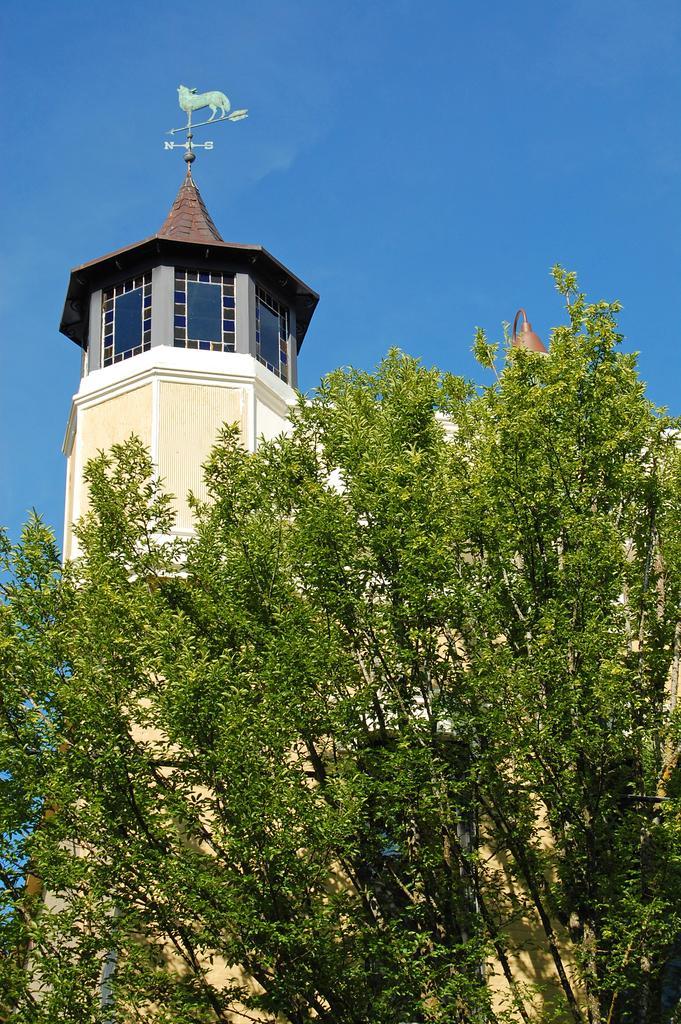How would you summarize this image in a sentence or two? In the picture I can see building and also I can see some trees and sky. 